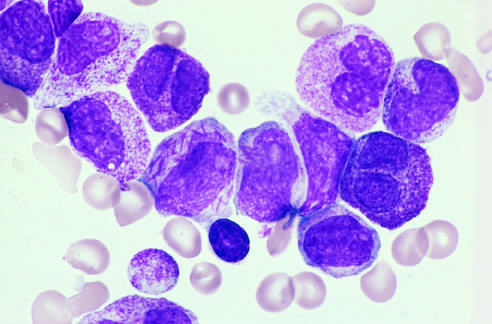do infected cells include a cell in the center of the field with multiple needlelike auer rods?
Answer the question using a single word or phrase. No 